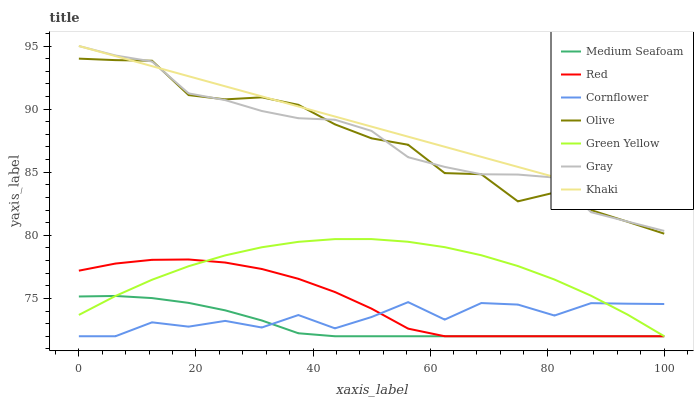Does Medium Seafoam have the minimum area under the curve?
Answer yes or no. Yes. Does Khaki have the maximum area under the curve?
Answer yes or no. Yes. Does Gray have the minimum area under the curve?
Answer yes or no. No. Does Gray have the maximum area under the curve?
Answer yes or no. No. Is Khaki the smoothest?
Answer yes or no. Yes. Is Cornflower the roughest?
Answer yes or no. Yes. Is Gray the smoothest?
Answer yes or no. No. Is Gray the roughest?
Answer yes or no. No. Does Cornflower have the lowest value?
Answer yes or no. Yes. Does Gray have the lowest value?
Answer yes or no. No. Does Gray have the highest value?
Answer yes or no. Yes. Does Olive have the highest value?
Answer yes or no. No. Is Medium Seafoam less than Gray?
Answer yes or no. Yes. Is Gray greater than Medium Seafoam?
Answer yes or no. Yes. Does Khaki intersect Olive?
Answer yes or no. Yes. Is Khaki less than Olive?
Answer yes or no. No. Is Khaki greater than Olive?
Answer yes or no. No. Does Medium Seafoam intersect Gray?
Answer yes or no. No. 